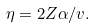<formula> <loc_0><loc_0><loc_500><loc_500>\eta = 2 Z \alpha / v .</formula> 